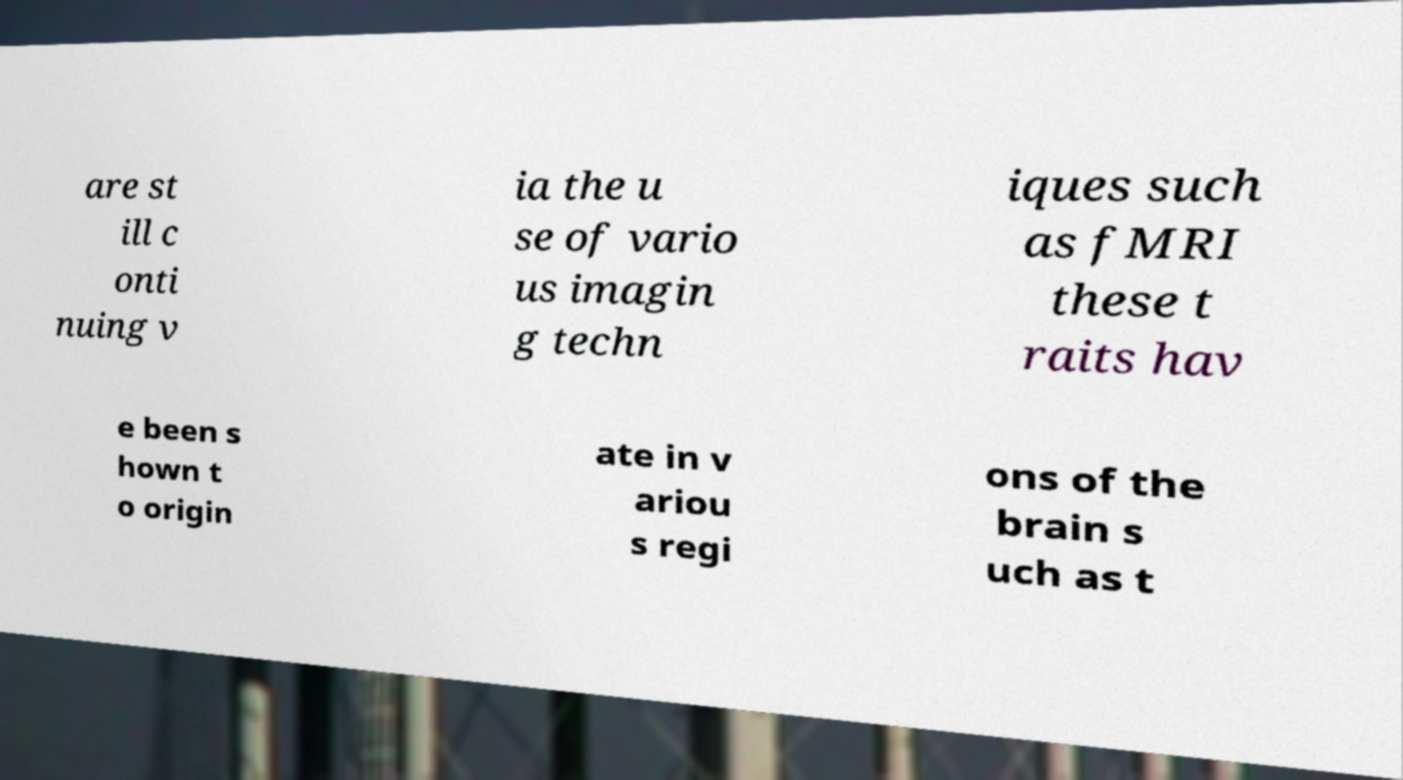Can you read and provide the text displayed in the image?This photo seems to have some interesting text. Can you extract and type it out for me? are st ill c onti nuing v ia the u se of vario us imagin g techn iques such as fMRI these t raits hav e been s hown t o origin ate in v ariou s regi ons of the brain s uch as t 